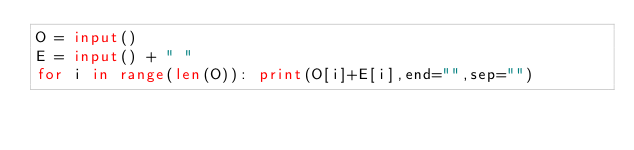Convert code to text. <code><loc_0><loc_0><loc_500><loc_500><_Python_>O = input()
E = input() + " "
for i in range(len(O)): print(O[i]+E[i],end="",sep="")
</code> 